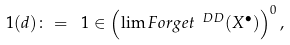<formula> <loc_0><loc_0><loc_500><loc_500>\ 1 ( d ) \colon = \ 1 \in \left ( \lim F o r g e t ^ { \ D D } ( X ^ { \bullet } ) \right ) ^ { 0 } ,</formula> 